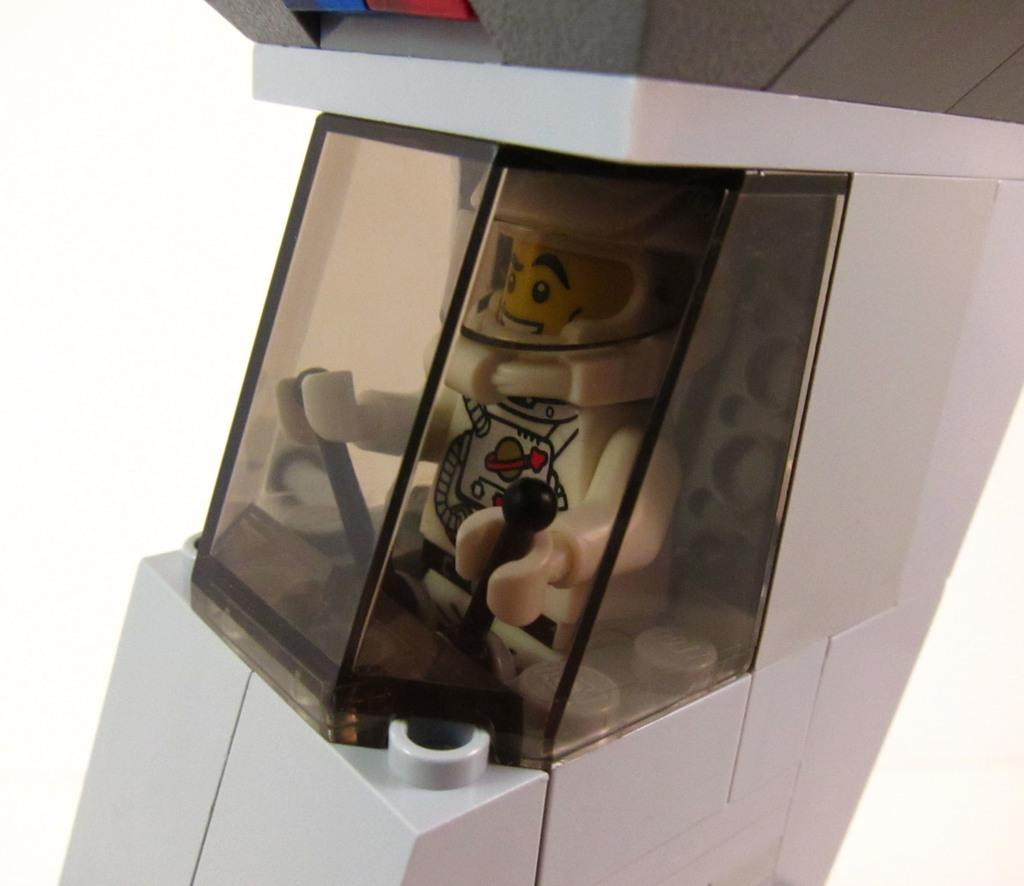What object can be seen in the image? There is a toy in the image. What color is the background of the image? The background of the image is white. What type of fish is the farmer holding in the image? There is no farmer or fish present in the image; it features a toy and a white background. 